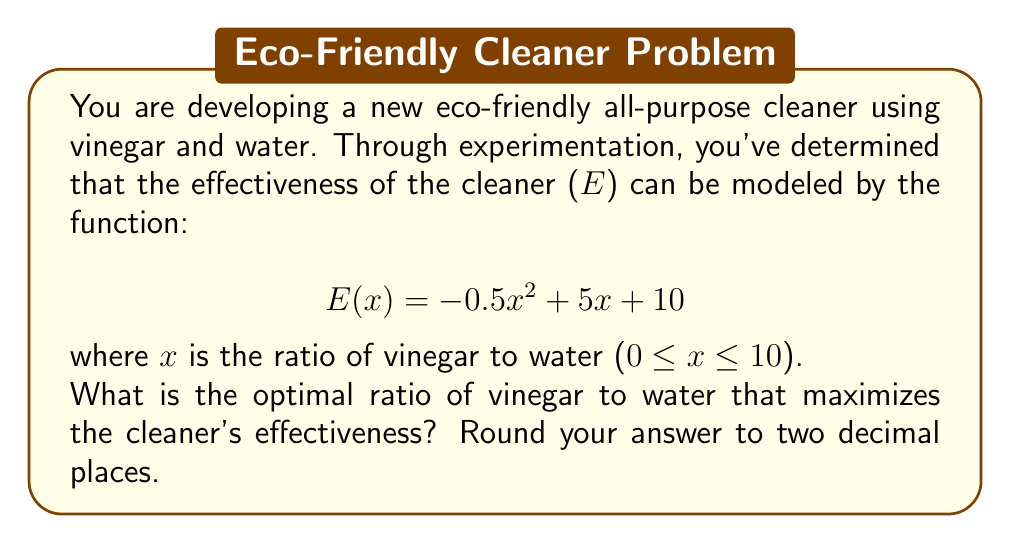Could you help me with this problem? To find the optimal ratio that maximizes the cleaner's effectiveness, we need to find the maximum of the quadratic function E(x).

1. The function E(x) is a quadratic function in the form of $$f(x) = ax^2 + bx + c$$
   where a = -0.5, b = 5, and c = 10.

2. For a quadratic function, the maximum (or minimum) occurs at the vertex. The x-coordinate of the vertex can be found using the formula:
   $$x = -\frac{b}{2a}$$

3. Substituting our values:
   $$x = -\frac{5}{2(-0.5)} = -\frac{5}{-1} = 5$$

4. To verify this is a maximum (not a minimum), we can check that a < 0 (-0.5 < 0), which confirms this is indeed a maximum.

5. The optimal ratio is therefore x = 5.

6. Rounding to two decimal places: 5.00

This means the optimal ratio is 5 parts vinegar to 1 part water, or a 5:1 ratio.
Answer: 5.00 